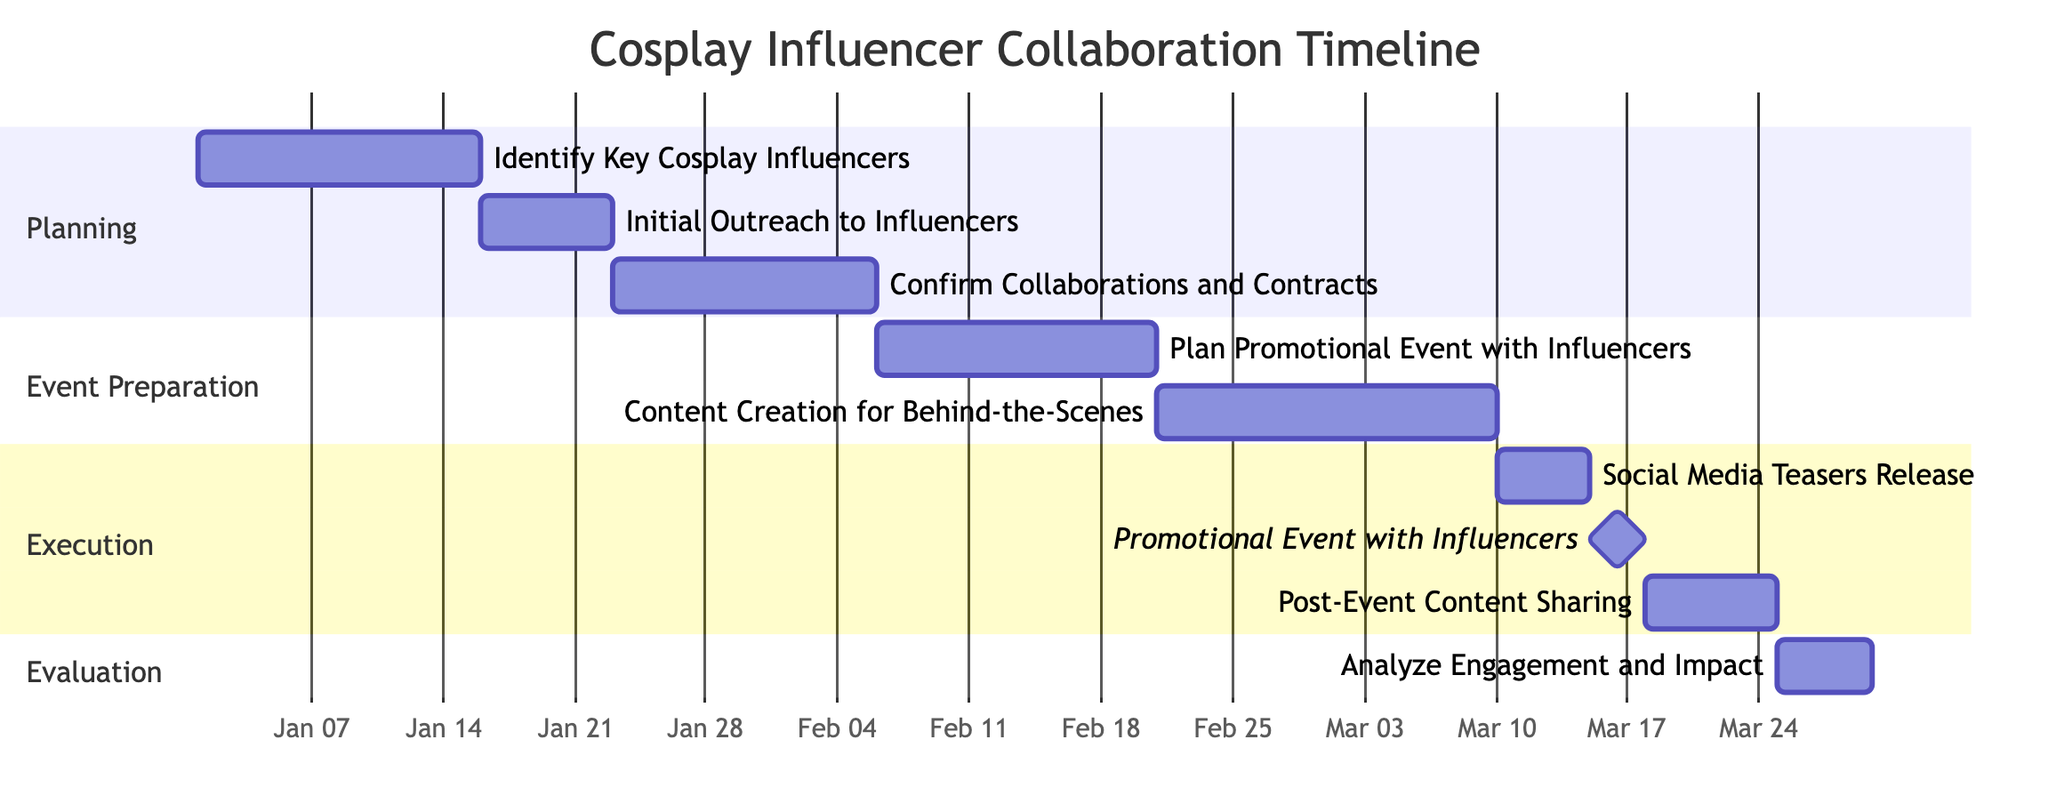What is the duration of the task "Initial Outreach to Influencers"? The task "Initial Outreach to Influencers" starts on 2024-01-16 and ends on 2024-01-22. This spans over a period of 7 days.
Answer: 7 days Which task follows "Social Media Teasers Release"? The task that follows "Social Media Teasers Release" is "Promotional Event with Influencers". By analyzing the timeline, "Promotional Event with Influencers" begins immediately after "Social Media Teasers Release" ends.
Answer: Promotional Event with Influencers What is the total number of main sections in the Gantt chart? The Gantt chart has four main sections: Planning, Event Preparation, Execution, and Evaluation. Each section groups related tasks together.
Answer: 4 What task has the earliest start date? To find the task with the earliest start date, we look at all tasks and find that "Identify Key Cosplay Influencers" starts on 2024-01-01, which is the earliest.
Answer: Identify Key Cosplay Influencers How many days are allocated for "Post-Event Content Sharing"? The task "Post-Event Content Sharing" starts on 2024-03-19 and ends on 2024-03-25, yielding a total duration of 7 days for this task.
Answer: 7 days What is the relationship between "Content Creation for Behind-the-Scenes" and "Promotional Event with Influencers"? "Content Creation for Behind-the-Scenes" must be completed prior to "Promotional Event with Influencers", as it follows directly in the timeline upon the completion of its own task, highlighting a sequential relationship.
Answer: Sequential Which task ends after the "Promotional Event with Influencers"? The task that ends after "Promotional Event with Influencers" is "Post-Event Content Sharing", as it immediately follows the promotional event in the timeline.
Answer: Post-Event Content Sharing What is the end date for the task "Analyze Engagement and Impact"? The task "Analyze Engagement and Impact" starts on 2024-03-26 and ends on 2024-03-30. Hence, the end date for this task is 2024-03-30.
Answer: 2024-03-30 